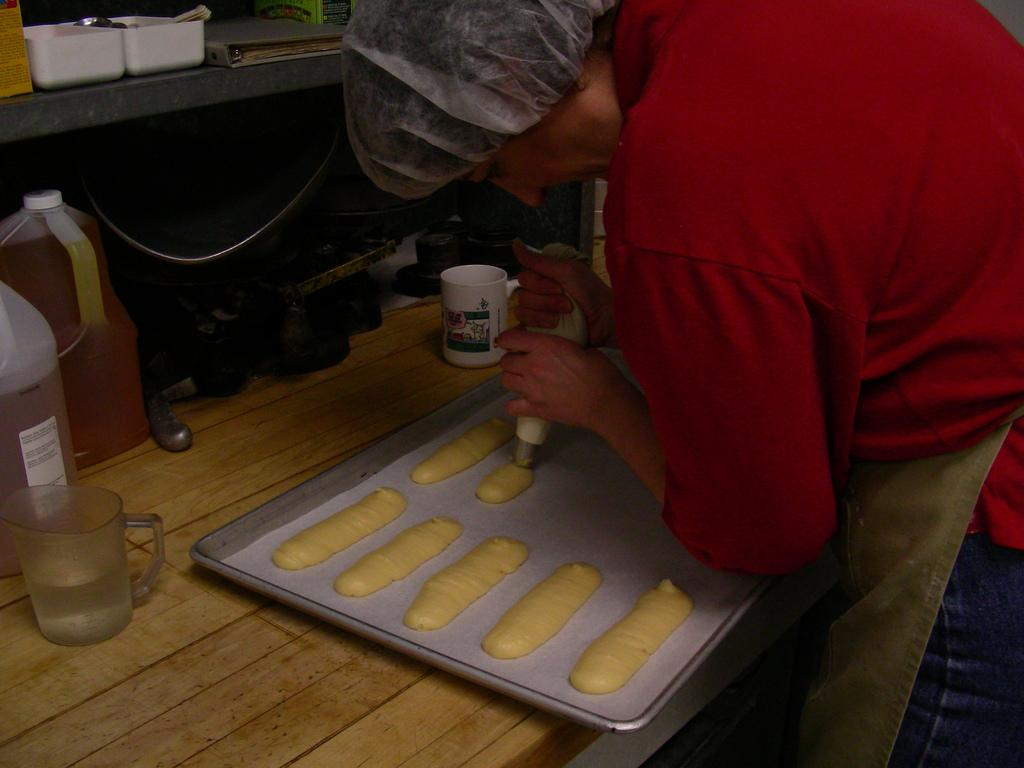Who is present in the image? There is a person in the image. What is the person wearing? The person is wearing a red shirt. What is the person doing in the image? The person is preparing food items. What is the setting for this activity? There is a table in the image. What type of ornament is hanging from the ceiling in the image? There is no ornament hanging from the ceiling in the image. 